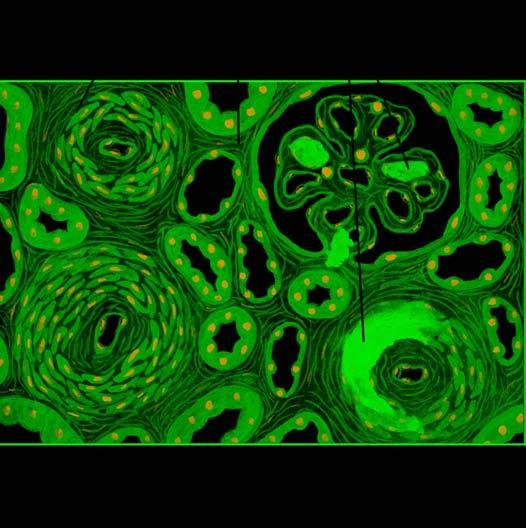how are the parenchymal changes?
Answer the question using a single word or phrase. Tubular loss 